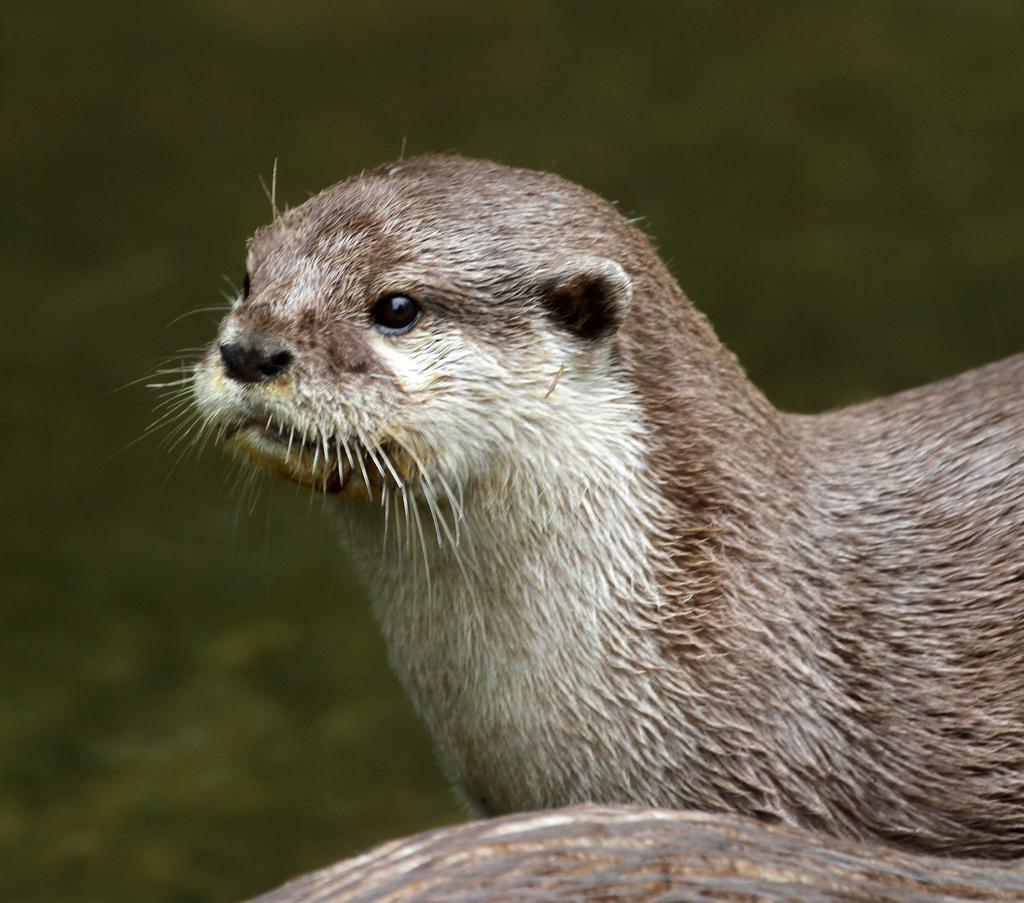In one or two sentences, can you explain what this image depicts? In the center of the image we can see an animal. 